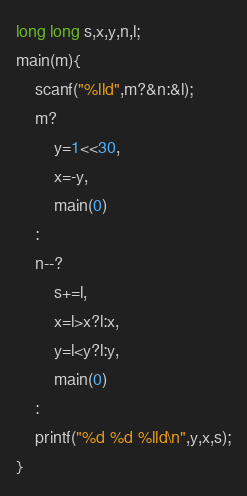<code> <loc_0><loc_0><loc_500><loc_500><_C_>long long s,x,y,n,l;
main(m){
	scanf("%lld",m?&n:&l);
	m?
		y=1<<30,
		x=-y,
		main(0)
	:
	n--?
		s+=l,
		x=l>x?l:x,
		y=l<y?l:y,
		main(0)
	:
	printf("%d %d %lld\n",y,x,s);
}
</code> 